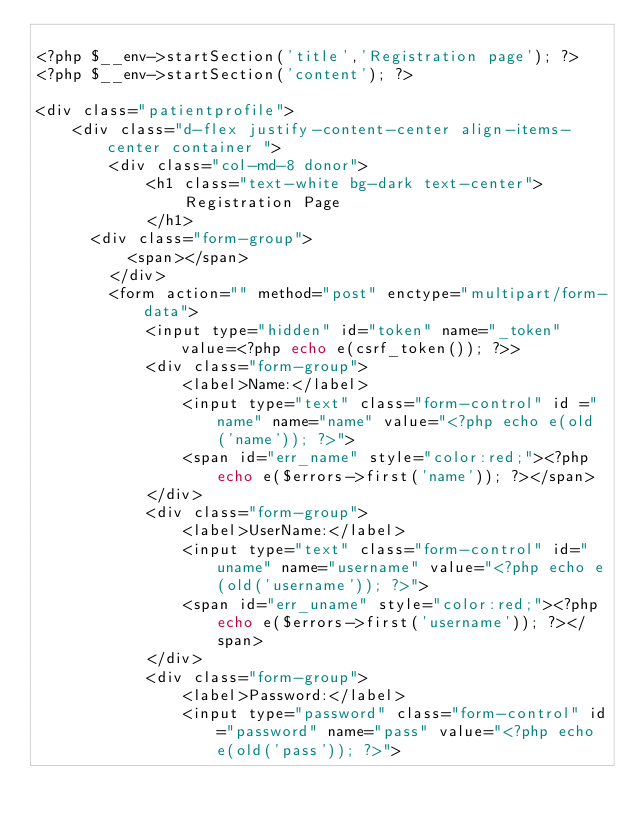<code> <loc_0><loc_0><loc_500><loc_500><_PHP_>
<?php $__env->startSection('title','Registration page'); ?>
<?php $__env->startSection('content'); ?>

<div class="patientprofile">
    <div class="d-flex justify-content-center align-items-center container ">
        <div class="col-md-8 donor">
            <h1 class="text-white bg-dark text-center">
                Registration Page
            </h1>
			<div class="form-group">
					<span></span>
				</div>
        <form action="" method="post" enctype="multipart/form-data">
            <input type="hidden" id="token" name="_token" value=<?php echo e(csrf_token()); ?>>
            <div class="form-group">
                <label>Name:</label>
                <input type="text" class="form-control" id ="name" name="name" value="<?php echo e(old('name')); ?>">
                <span id="err_name" style="color:red;"><?php echo e($errors->first('name')); ?></span>
            </div>
            <div class="form-group">
                <label>UserName:</label>
                <input type="text" class="form-control" id="uname" name="username" value="<?php echo e(old('username')); ?>">
                <span id="err_uname" style="color:red;"><?php echo e($errors->first('username')); ?></span>
            </div>
            <div class="form-group">
                <label>Password:</label>
                <input type="password" class="form-control" id="password" name="pass" value="<?php echo e(old('pass')); ?>"></code> 